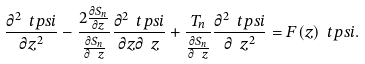<formula> <loc_0><loc_0><loc_500><loc_500>\frac { \partial ^ { 2 } \ t p s i } { \partial z ^ { 2 } } - \frac { 2 \frac { \partial S _ { n } } { \partial z } } { \frac { \partial S _ { n } } { \partial \ z } } \frac { \partial ^ { 2 } \ t p s i } { \partial z \partial \ z } + \frac { T _ { n } } { \frac { \partial S _ { n } } { \partial \ z } } \frac { \partial ^ { 2 } \ t p s i } { \partial \ z ^ { 2 } } = F ( z ) \ t p s i .</formula> 